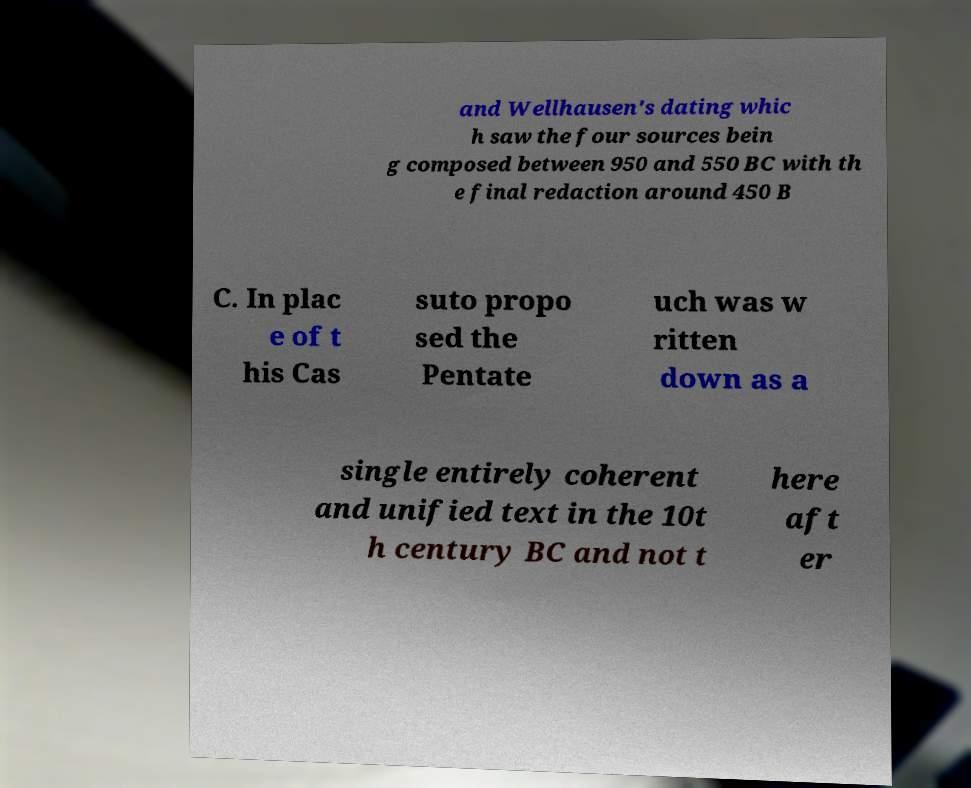Please identify and transcribe the text found in this image. and Wellhausen's dating whic h saw the four sources bein g composed between 950 and 550 BC with th e final redaction around 450 B C. In plac e of t his Cas suto propo sed the Pentate uch was w ritten down as a single entirely coherent and unified text in the 10t h century BC and not t here aft er 